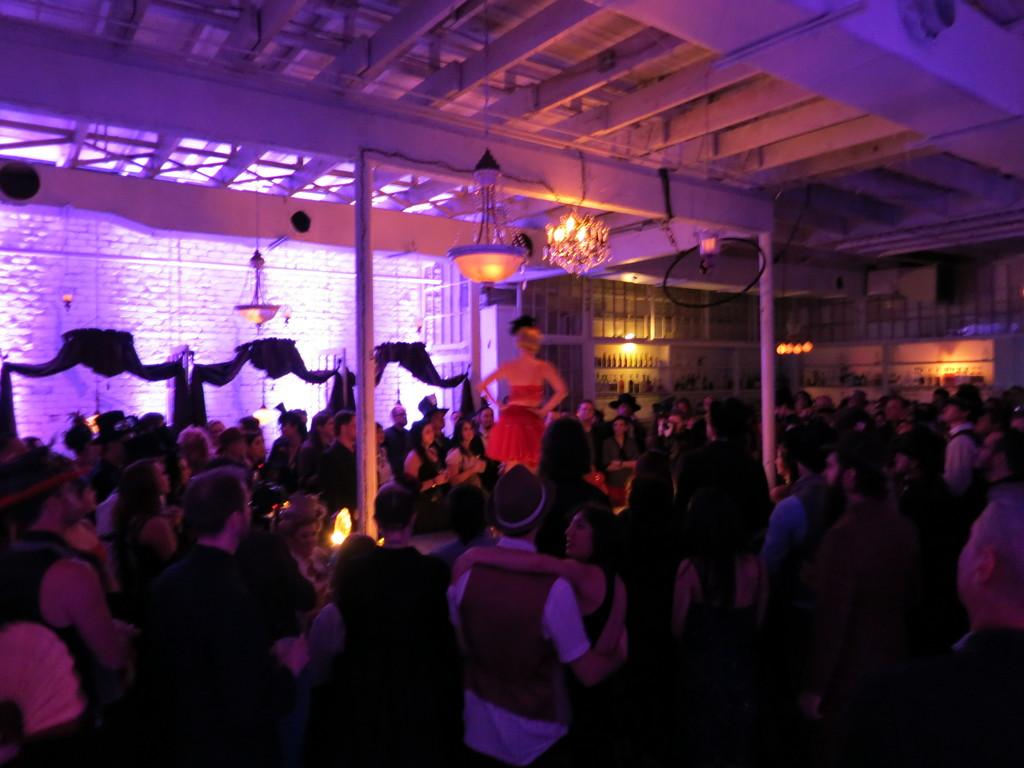What can be seen in the image in terms of human presence? There are groups of people in the image. What architectural features are present in front of the people? There are pillars in front of the people. What type of lighting is visible in the image? There are chandeliers hanging from the ceiling at the top of the image. What type of oven can be seen in the image? There is no oven present in the image. What kind of pipe is visible in the image? There is no pipe visible in the image. 